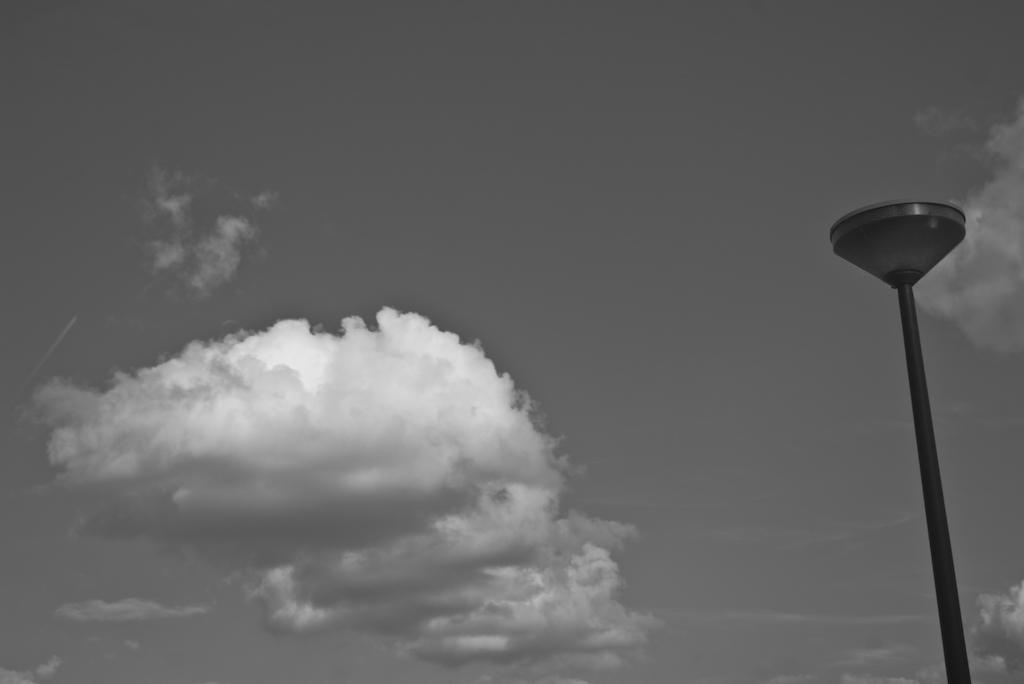What can be seen in the sky in the image? There are clouds in the sky in the image. What object is located on the right side of the image? There is a pole on the right side of the image. How is the image presented in terms of color? The image is in black and white color. Where is the field of honey located in the image? There is no field of honey present in the image. What type of coal can be seen in the image? There is no coal present in the image. 